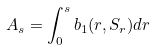Convert formula to latex. <formula><loc_0><loc_0><loc_500><loc_500>A _ { s } = \int _ { 0 } ^ { s } b _ { 1 } ( r , S _ { r } ) d r</formula> 